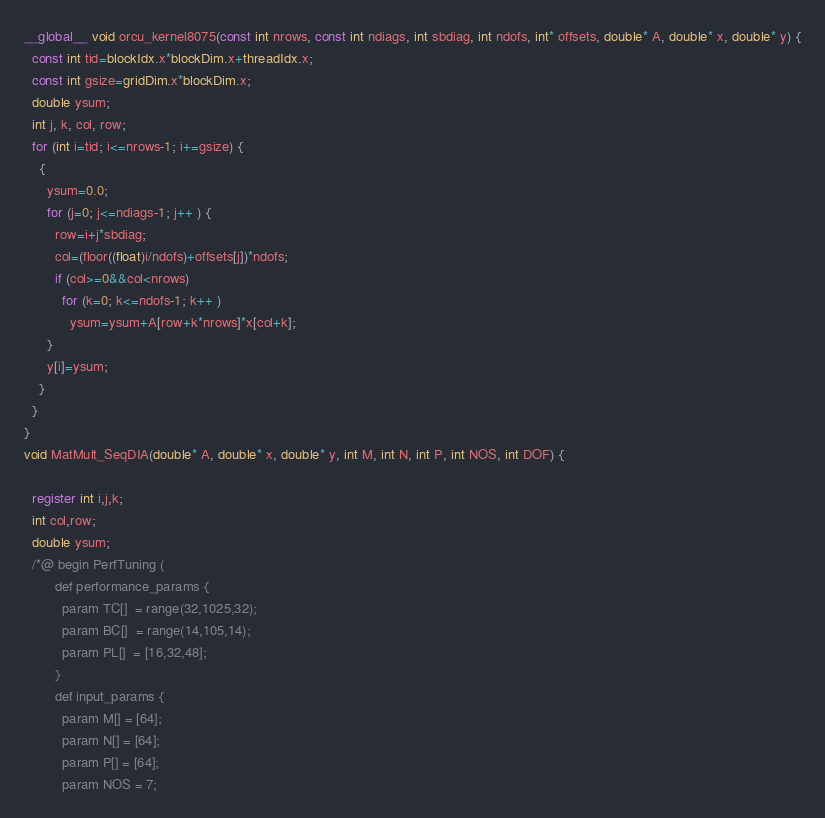<code> <loc_0><loc_0><loc_500><loc_500><_Cuda_>__global__ void orcu_kernel8075(const int nrows, const int ndiags, int sbdiag, int ndofs, int* offsets, double* A, double* x, double* y) {
  const int tid=blockIdx.x*blockDim.x+threadIdx.x;
  const int gsize=gridDim.x*blockDim.x;
  double ysum;
  int j, k, col, row;
  for (int i=tid; i<=nrows-1; i+=gsize) {
    {
      ysum=0.0;
      for (j=0; j<=ndiags-1; j++ ) {
        row=i+j*sbdiag;
        col=(floor((float)i/ndofs)+offsets[j])*ndofs;
        if (col>=0&&col<nrows) 
          for (k=0; k<=ndofs-1; k++ ) 
            ysum=ysum+A[row+k*nrows]*x[col+k];
      }
      y[i]=ysum;
    }
  }
}
void MatMult_SeqDIA(double* A, double* x, double* y, int M, int N, int P, int NOS, int DOF) {

  register int i,j,k;
  int col,row;
  double ysum;
  /*@ begin PerfTuning (
        def performance_params {
          param TC[]  = range(32,1025,32);
          param BC[]  = range(14,105,14);
          param PL[]  = [16,32,48];
        }
        def input_params {
          param M[] = [64];
          param N[] = [64];
          param P[] = [64];
          param NOS = 7;</code> 